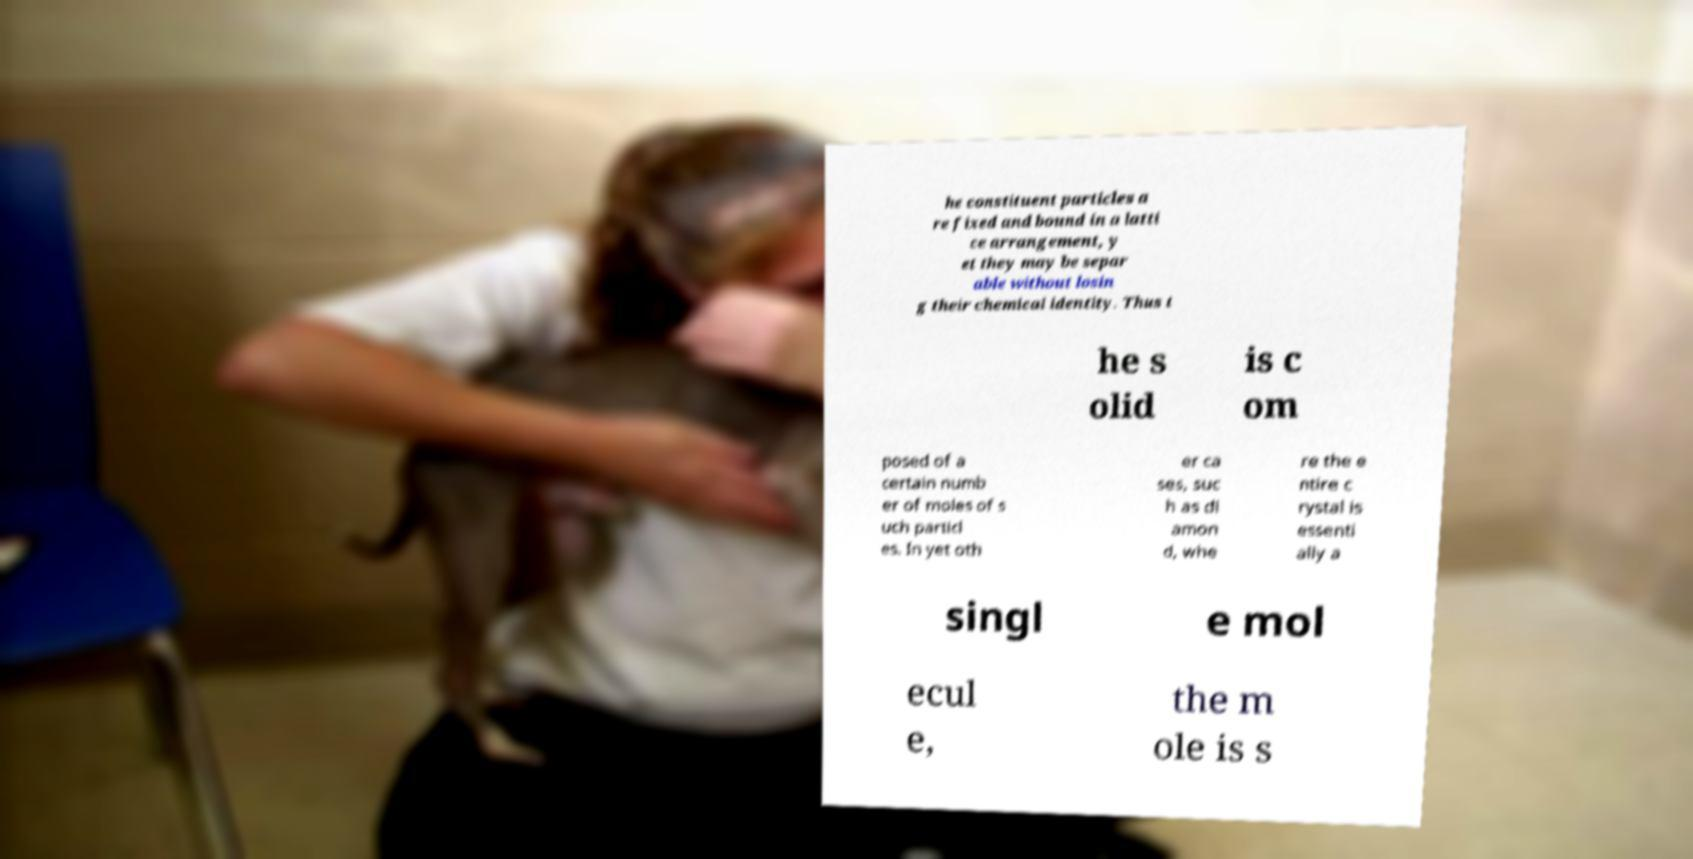Can you read and provide the text displayed in the image?This photo seems to have some interesting text. Can you extract and type it out for me? he constituent particles a re fixed and bound in a latti ce arrangement, y et they may be separ able without losin g their chemical identity. Thus t he s olid is c om posed of a certain numb er of moles of s uch particl es. In yet oth er ca ses, suc h as di amon d, whe re the e ntire c rystal is essenti ally a singl e mol ecul e, the m ole is s 